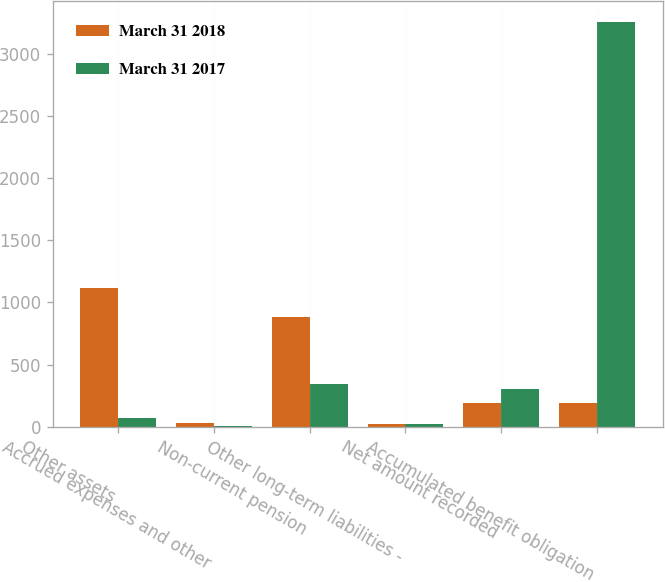Convert chart to OTSL. <chart><loc_0><loc_0><loc_500><loc_500><stacked_bar_chart><ecel><fcel>Other assets<fcel>Accrued expenses and other<fcel>Non-current pension<fcel>Other long-term liabilities -<fcel>Net amount recorded<fcel>Accumulated benefit obligation<nl><fcel>March 31 2018<fcel>1118<fcel>28<fcel>879<fcel>21<fcel>190<fcel>190<nl><fcel>March 31 2017<fcel>73<fcel>7<fcel>342<fcel>23<fcel>299<fcel>3262<nl></chart> 